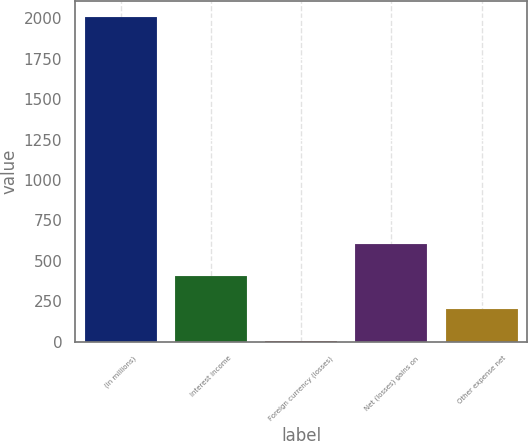<chart> <loc_0><loc_0><loc_500><loc_500><bar_chart><fcel>(in millions)<fcel>Interest income<fcel>Foreign currency (losses)<fcel>Net (losses) gains on<fcel>Other expense net<nl><fcel>2008<fcel>405.6<fcel>5<fcel>605.9<fcel>205.3<nl></chart> 